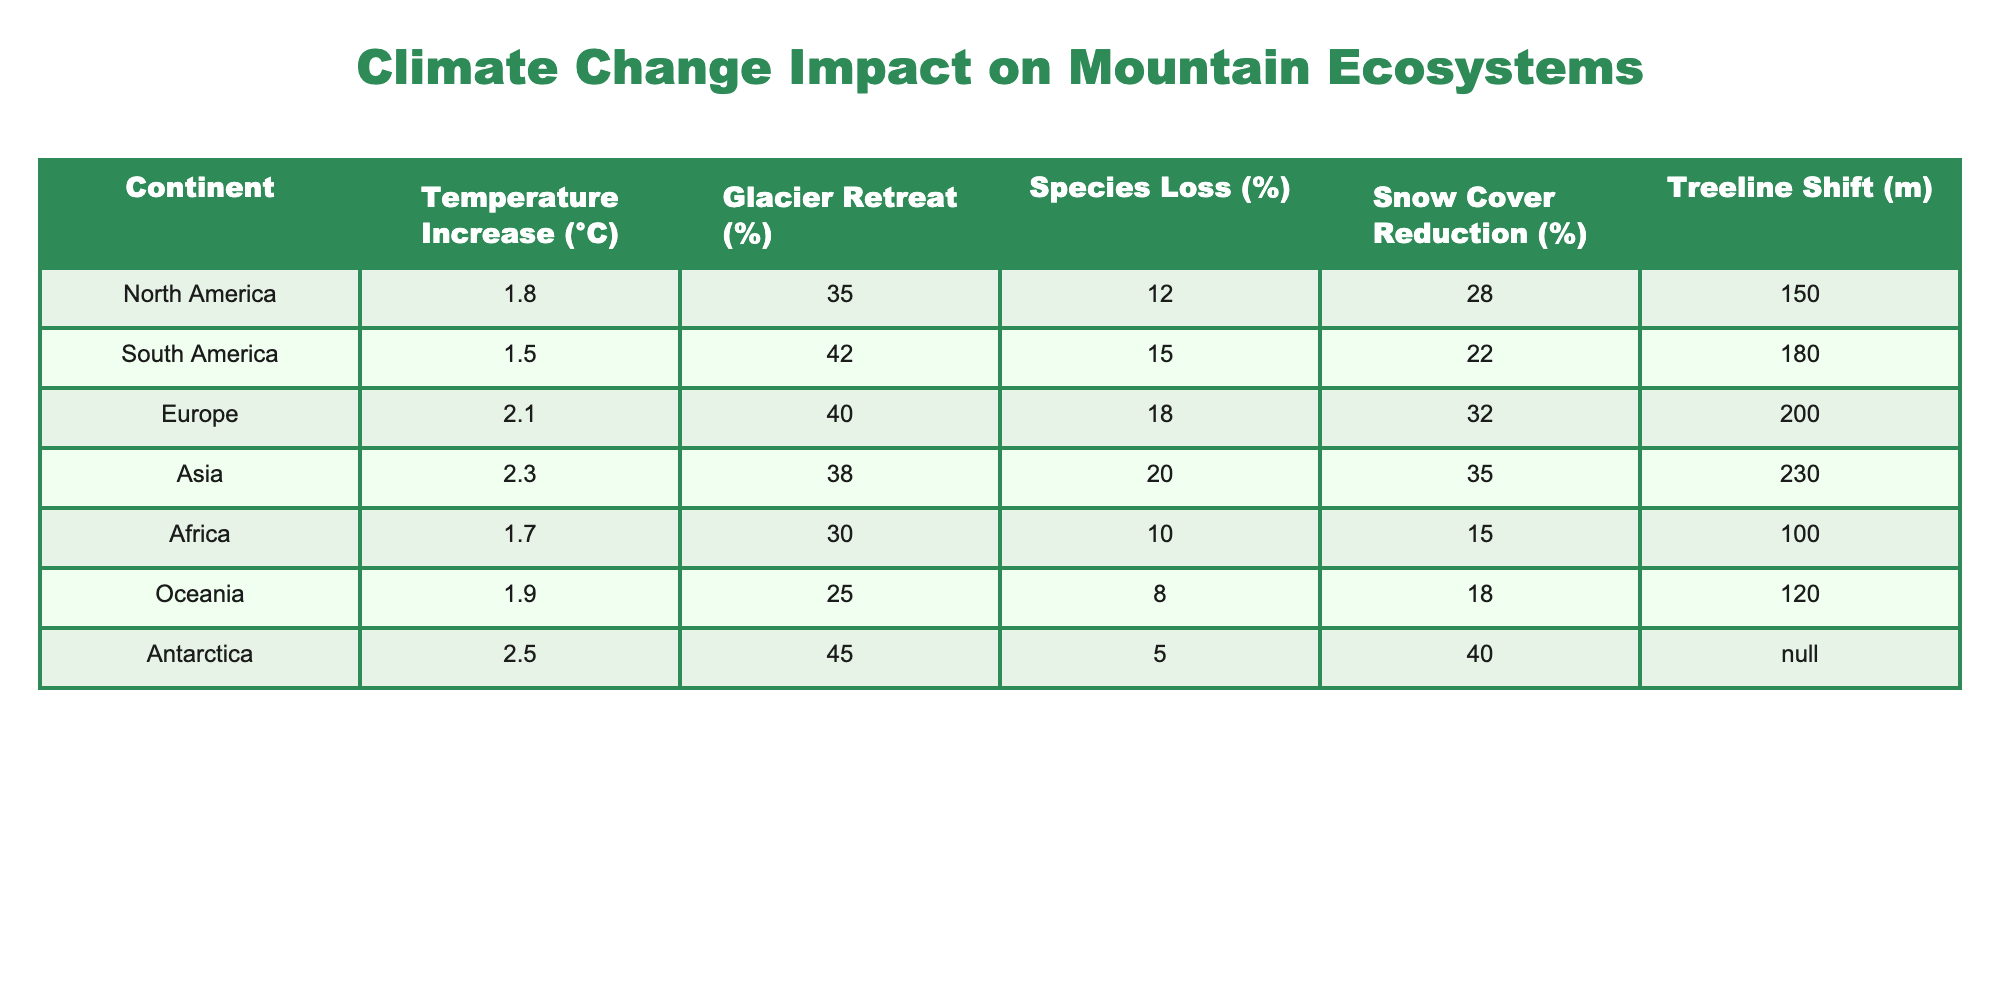What is the temperature increase recorded for Asia? According to the table, Asia has a temperature increase of 2.3 degrees Celsius.
Answer: 2.3 °C Which continent has the highest percentage of glacier retreat? The table indicates that Antarctica has the highest glacier retreat at 45%.
Answer: 45% What is the average species loss percentage across all continents? To calculate the average, we sum the species loss percentages (12 + 15 + 18 + 20 + 10 + 8 + 5 = 88) and divide by the number of continents (7); thus, the average is 88/7 ≈ 12.57%.
Answer: 12.57% Is the treeline shift in South America greater than that in North America? South America has a treeline shift of 180 meters while North America has a shift of 150 meters, so yes.
Answer: Yes Which continent shows the least reduction in snow cover? By examining the table, Oceania shows a reduction of 18%, which is the least compared to other continents.
Answer: 18% What is the difference in glacier retreat percentage between Europe and Oceania? The glacier retreat for Europe is 40% and for Oceania is 25%. The difference is 40% - 25% = 15%.
Answer: 15% Which continent has both the highest temperature increase and the highest glacier retreat? The table reveals that Antarctica has the highest temperature increase (2.5 °C) and also the highest glacier retreat (45%), making it the only continent with these distinctions.
Answer: Antarctica Is there a correlation between temperature increase and snow cover reduction across the continents? Analyzing the data, we find that as temperature increases, snow cover reduction also tends to increase. For example, Asia has the highest temperature increase with the greatest snow cover reduction at 35%.
Answer: Yes What is the treeline shift in Africa compared to Antarctica? Africa's treeline shift is 100 meters, while Antarctica's value is not applicable (N/A). Therefore, we can't make a direct comparison as Antarctica lacks a value for treeline shift.
Answer: Not applicable (N/A) How much greater is the species loss in Asia than that in Oceania? The species loss in Asia is 20% and in Oceania it is 8%. The difference is 20% - 8% = 12%.
Answer: 12% 